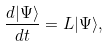<formula> <loc_0><loc_0><loc_500><loc_500>\frac { d | \Psi \rangle } { d t } = L | \Psi \rangle ,</formula> 